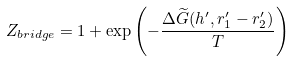Convert formula to latex. <formula><loc_0><loc_0><loc_500><loc_500>Z _ { b r i d g e } = 1 + \exp \left ( - \frac { \Delta \widetilde { G } ( h ^ { \prime } , r _ { 1 } ^ { \prime } - r _ { 2 } ^ { \prime } ) } { T } \right )</formula> 